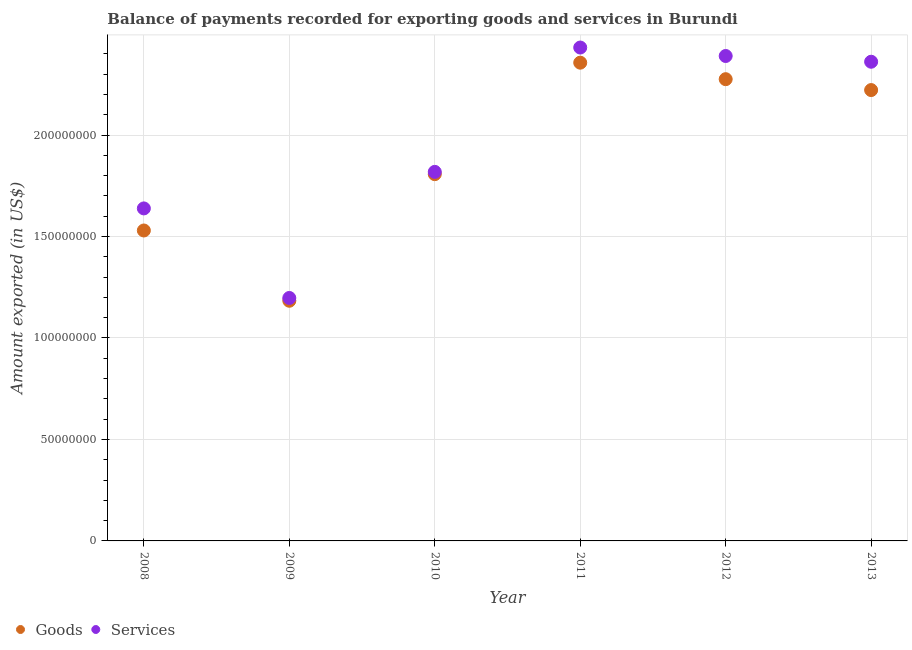How many different coloured dotlines are there?
Give a very brief answer. 2. Is the number of dotlines equal to the number of legend labels?
Keep it short and to the point. Yes. What is the amount of services exported in 2009?
Keep it short and to the point. 1.20e+08. Across all years, what is the maximum amount of services exported?
Provide a short and direct response. 2.43e+08. Across all years, what is the minimum amount of goods exported?
Your answer should be very brief. 1.18e+08. In which year was the amount of services exported minimum?
Make the answer very short. 2009. What is the total amount of goods exported in the graph?
Keep it short and to the point. 1.14e+09. What is the difference between the amount of goods exported in 2011 and that in 2012?
Make the answer very short. 8.13e+06. What is the difference between the amount of goods exported in 2011 and the amount of services exported in 2010?
Offer a very short reply. 5.38e+07. What is the average amount of services exported per year?
Provide a short and direct response. 1.97e+08. In the year 2010, what is the difference between the amount of services exported and amount of goods exported?
Offer a very short reply. 1.13e+06. What is the ratio of the amount of goods exported in 2009 to that in 2010?
Offer a very short reply. 0.65. Is the amount of services exported in 2010 less than that in 2012?
Your answer should be compact. Yes. What is the difference between the highest and the second highest amount of goods exported?
Ensure brevity in your answer.  8.13e+06. What is the difference between the highest and the lowest amount of services exported?
Your answer should be compact. 1.23e+08. In how many years, is the amount of services exported greater than the average amount of services exported taken over all years?
Ensure brevity in your answer.  3. Is the amount of services exported strictly greater than the amount of goods exported over the years?
Provide a succinct answer. Yes. How many dotlines are there?
Offer a very short reply. 2. Are the values on the major ticks of Y-axis written in scientific E-notation?
Offer a very short reply. No. Does the graph contain any zero values?
Keep it short and to the point. No. Does the graph contain grids?
Ensure brevity in your answer.  Yes. Where does the legend appear in the graph?
Offer a very short reply. Bottom left. How are the legend labels stacked?
Provide a short and direct response. Horizontal. What is the title of the graph?
Keep it short and to the point. Balance of payments recorded for exporting goods and services in Burundi. What is the label or title of the X-axis?
Give a very brief answer. Year. What is the label or title of the Y-axis?
Offer a very short reply. Amount exported (in US$). What is the Amount exported (in US$) in Goods in 2008?
Ensure brevity in your answer.  1.53e+08. What is the Amount exported (in US$) of Services in 2008?
Provide a short and direct response. 1.64e+08. What is the Amount exported (in US$) in Goods in 2009?
Your answer should be very brief. 1.18e+08. What is the Amount exported (in US$) in Services in 2009?
Keep it short and to the point. 1.20e+08. What is the Amount exported (in US$) in Goods in 2010?
Your answer should be very brief. 1.81e+08. What is the Amount exported (in US$) of Services in 2010?
Ensure brevity in your answer.  1.82e+08. What is the Amount exported (in US$) in Goods in 2011?
Your answer should be compact. 2.36e+08. What is the Amount exported (in US$) of Services in 2011?
Provide a succinct answer. 2.43e+08. What is the Amount exported (in US$) in Goods in 2012?
Offer a very short reply. 2.28e+08. What is the Amount exported (in US$) in Services in 2012?
Ensure brevity in your answer.  2.39e+08. What is the Amount exported (in US$) of Goods in 2013?
Your answer should be compact. 2.22e+08. What is the Amount exported (in US$) in Services in 2013?
Give a very brief answer. 2.36e+08. Across all years, what is the maximum Amount exported (in US$) of Goods?
Offer a terse response. 2.36e+08. Across all years, what is the maximum Amount exported (in US$) of Services?
Offer a terse response. 2.43e+08. Across all years, what is the minimum Amount exported (in US$) in Goods?
Your response must be concise. 1.18e+08. Across all years, what is the minimum Amount exported (in US$) in Services?
Give a very brief answer. 1.20e+08. What is the total Amount exported (in US$) in Goods in the graph?
Provide a short and direct response. 1.14e+09. What is the total Amount exported (in US$) of Services in the graph?
Provide a succinct answer. 1.18e+09. What is the difference between the Amount exported (in US$) in Goods in 2008 and that in 2009?
Provide a succinct answer. 3.46e+07. What is the difference between the Amount exported (in US$) of Services in 2008 and that in 2009?
Make the answer very short. 4.41e+07. What is the difference between the Amount exported (in US$) in Goods in 2008 and that in 2010?
Your response must be concise. -2.78e+07. What is the difference between the Amount exported (in US$) in Services in 2008 and that in 2010?
Keep it short and to the point. -1.80e+07. What is the difference between the Amount exported (in US$) in Goods in 2008 and that in 2011?
Give a very brief answer. -8.27e+07. What is the difference between the Amount exported (in US$) of Services in 2008 and that in 2011?
Offer a very short reply. -7.93e+07. What is the difference between the Amount exported (in US$) of Goods in 2008 and that in 2012?
Provide a short and direct response. -7.46e+07. What is the difference between the Amount exported (in US$) of Services in 2008 and that in 2012?
Provide a short and direct response. -7.51e+07. What is the difference between the Amount exported (in US$) of Goods in 2008 and that in 2013?
Your response must be concise. -6.92e+07. What is the difference between the Amount exported (in US$) of Services in 2008 and that in 2013?
Ensure brevity in your answer.  -7.23e+07. What is the difference between the Amount exported (in US$) of Goods in 2009 and that in 2010?
Your response must be concise. -6.24e+07. What is the difference between the Amount exported (in US$) in Services in 2009 and that in 2010?
Your response must be concise. -6.21e+07. What is the difference between the Amount exported (in US$) in Goods in 2009 and that in 2011?
Keep it short and to the point. -1.17e+08. What is the difference between the Amount exported (in US$) of Services in 2009 and that in 2011?
Keep it short and to the point. -1.23e+08. What is the difference between the Amount exported (in US$) in Goods in 2009 and that in 2012?
Keep it short and to the point. -1.09e+08. What is the difference between the Amount exported (in US$) in Services in 2009 and that in 2012?
Give a very brief answer. -1.19e+08. What is the difference between the Amount exported (in US$) of Goods in 2009 and that in 2013?
Keep it short and to the point. -1.04e+08. What is the difference between the Amount exported (in US$) of Services in 2009 and that in 2013?
Your answer should be compact. -1.16e+08. What is the difference between the Amount exported (in US$) in Goods in 2010 and that in 2011?
Make the answer very short. -5.49e+07. What is the difference between the Amount exported (in US$) in Services in 2010 and that in 2011?
Make the answer very short. -6.13e+07. What is the difference between the Amount exported (in US$) of Goods in 2010 and that in 2012?
Your answer should be very brief. -4.68e+07. What is the difference between the Amount exported (in US$) in Services in 2010 and that in 2012?
Your answer should be compact. -5.71e+07. What is the difference between the Amount exported (in US$) of Goods in 2010 and that in 2013?
Make the answer very short. -4.14e+07. What is the difference between the Amount exported (in US$) of Services in 2010 and that in 2013?
Offer a very short reply. -5.43e+07. What is the difference between the Amount exported (in US$) of Goods in 2011 and that in 2012?
Provide a short and direct response. 8.13e+06. What is the difference between the Amount exported (in US$) of Services in 2011 and that in 2012?
Provide a short and direct response. 4.17e+06. What is the difference between the Amount exported (in US$) in Goods in 2011 and that in 2013?
Your answer should be very brief. 1.35e+07. What is the difference between the Amount exported (in US$) of Services in 2011 and that in 2013?
Ensure brevity in your answer.  7.00e+06. What is the difference between the Amount exported (in US$) in Goods in 2012 and that in 2013?
Provide a short and direct response. 5.37e+06. What is the difference between the Amount exported (in US$) of Services in 2012 and that in 2013?
Make the answer very short. 2.83e+06. What is the difference between the Amount exported (in US$) of Goods in 2008 and the Amount exported (in US$) of Services in 2009?
Your response must be concise. 3.33e+07. What is the difference between the Amount exported (in US$) of Goods in 2008 and the Amount exported (in US$) of Services in 2010?
Your response must be concise. -2.89e+07. What is the difference between the Amount exported (in US$) of Goods in 2008 and the Amount exported (in US$) of Services in 2011?
Provide a short and direct response. -9.02e+07. What is the difference between the Amount exported (in US$) in Goods in 2008 and the Amount exported (in US$) in Services in 2012?
Provide a succinct answer. -8.60e+07. What is the difference between the Amount exported (in US$) of Goods in 2008 and the Amount exported (in US$) of Services in 2013?
Provide a short and direct response. -8.32e+07. What is the difference between the Amount exported (in US$) in Goods in 2009 and the Amount exported (in US$) in Services in 2010?
Your answer should be compact. -6.35e+07. What is the difference between the Amount exported (in US$) in Goods in 2009 and the Amount exported (in US$) in Services in 2011?
Make the answer very short. -1.25e+08. What is the difference between the Amount exported (in US$) in Goods in 2009 and the Amount exported (in US$) in Services in 2012?
Ensure brevity in your answer.  -1.21e+08. What is the difference between the Amount exported (in US$) in Goods in 2009 and the Amount exported (in US$) in Services in 2013?
Make the answer very short. -1.18e+08. What is the difference between the Amount exported (in US$) of Goods in 2010 and the Amount exported (in US$) of Services in 2011?
Ensure brevity in your answer.  -6.24e+07. What is the difference between the Amount exported (in US$) of Goods in 2010 and the Amount exported (in US$) of Services in 2012?
Your answer should be compact. -5.82e+07. What is the difference between the Amount exported (in US$) in Goods in 2010 and the Amount exported (in US$) in Services in 2013?
Offer a terse response. -5.54e+07. What is the difference between the Amount exported (in US$) of Goods in 2011 and the Amount exported (in US$) of Services in 2012?
Give a very brief answer. -3.29e+06. What is the difference between the Amount exported (in US$) of Goods in 2011 and the Amount exported (in US$) of Services in 2013?
Provide a short and direct response. -4.61e+05. What is the difference between the Amount exported (in US$) in Goods in 2012 and the Amount exported (in US$) in Services in 2013?
Your answer should be very brief. -8.59e+06. What is the average Amount exported (in US$) in Goods per year?
Provide a short and direct response. 1.90e+08. What is the average Amount exported (in US$) in Services per year?
Make the answer very short. 1.97e+08. In the year 2008, what is the difference between the Amount exported (in US$) in Goods and Amount exported (in US$) in Services?
Your answer should be compact. -1.09e+07. In the year 2009, what is the difference between the Amount exported (in US$) of Goods and Amount exported (in US$) of Services?
Make the answer very short. -1.38e+06. In the year 2010, what is the difference between the Amount exported (in US$) in Goods and Amount exported (in US$) in Services?
Offer a terse response. -1.13e+06. In the year 2011, what is the difference between the Amount exported (in US$) of Goods and Amount exported (in US$) of Services?
Your response must be concise. -7.46e+06. In the year 2012, what is the difference between the Amount exported (in US$) in Goods and Amount exported (in US$) in Services?
Your answer should be compact. -1.14e+07. In the year 2013, what is the difference between the Amount exported (in US$) of Goods and Amount exported (in US$) of Services?
Give a very brief answer. -1.40e+07. What is the ratio of the Amount exported (in US$) in Goods in 2008 to that in 2009?
Your answer should be compact. 1.29. What is the ratio of the Amount exported (in US$) in Services in 2008 to that in 2009?
Your answer should be very brief. 1.37. What is the ratio of the Amount exported (in US$) of Goods in 2008 to that in 2010?
Keep it short and to the point. 0.85. What is the ratio of the Amount exported (in US$) in Services in 2008 to that in 2010?
Offer a very short reply. 0.9. What is the ratio of the Amount exported (in US$) in Goods in 2008 to that in 2011?
Provide a short and direct response. 0.65. What is the ratio of the Amount exported (in US$) in Services in 2008 to that in 2011?
Provide a short and direct response. 0.67. What is the ratio of the Amount exported (in US$) of Goods in 2008 to that in 2012?
Provide a succinct answer. 0.67. What is the ratio of the Amount exported (in US$) of Services in 2008 to that in 2012?
Ensure brevity in your answer.  0.69. What is the ratio of the Amount exported (in US$) of Goods in 2008 to that in 2013?
Offer a very short reply. 0.69. What is the ratio of the Amount exported (in US$) in Services in 2008 to that in 2013?
Keep it short and to the point. 0.69. What is the ratio of the Amount exported (in US$) of Goods in 2009 to that in 2010?
Make the answer very short. 0.65. What is the ratio of the Amount exported (in US$) of Services in 2009 to that in 2010?
Offer a very short reply. 0.66. What is the ratio of the Amount exported (in US$) in Goods in 2009 to that in 2011?
Provide a short and direct response. 0.5. What is the ratio of the Amount exported (in US$) of Services in 2009 to that in 2011?
Your answer should be compact. 0.49. What is the ratio of the Amount exported (in US$) in Goods in 2009 to that in 2012?
Give a very brief answer. 0.52. What is the ratio of the Amount exported (in US$) of Services in 2009 to that in 2012?
Offer a very short reply. 0.5. What is the ratio of the Amount exported (in US$) in Goods in 2009 to that in 2013?
Provide a short and direct response. 0.53. What is the ratio of the Amount exported (in US$) in Services in 2009 to that in 2013?
Make the answer very short. 0.51. What is the ratio of the Amount exported (in US$) in Goods in 2010 to that in 2011?
Your response must be concise. 0.77. What is the ratio of the Amount exported (in US$) of Services in 2010 to that in 2011?
Offer a very short reply. 0.75. What is the ratio of the Amount exported (in US$) in Goods in 2010 to that in 2012?
Keep it short and to the point. 0.79. What is the ratio of the Amount exported (in US$) of Services in 2010 to that in 2012?
Give a very brief answer. 0.76. What is the ratio of the Amount exported (in US$) in Goods in 2010 to that in 2013?
Offer a terse response. 0.81. What is the ratio of the Amount exported (in US$) in Services in 2010 to that in 2013?
Offer a very short reply. 0.77. What is the ratio of the Amount exported (in US$) in Goods in 2011 to that in 2012?
Your answer should be very brief. 1.04. What is the ratio of the Amount exported (in US$) of Services in 2011 to that in 2012?
Your response must be concise. 1.02. What is the ratio of the Amount exported (in US$) in Goods in 2011 to that in 2013?
Provide a short and direct response. 1.06. What is the ratio of the Amount exported (in US$) of Services in 2011 to that in 2013?
Your response must be concise. 1.03. What is the ratio of the Amount exported (in US$) of Goods in 2012 to that in 2013?
Provide a succinct answer. 1.02. What is the difference between the highest and the second highest Amount exported (in US$) in Goods?
Give a very brief answer. 8.13e+06. What is the difference between the highest and the second highest Amount exported (in US$) of Services?
Offer a terse response. 4.17e+06. What is the difference between the highest and the lowest Amount exported (in US$) in Goods?
Offer a terse response. 1.17e+08. What is the difference between the highest and the lowest Amount exported (in US$) in Services?
Provide a short and direct response. 1.23e+08. 